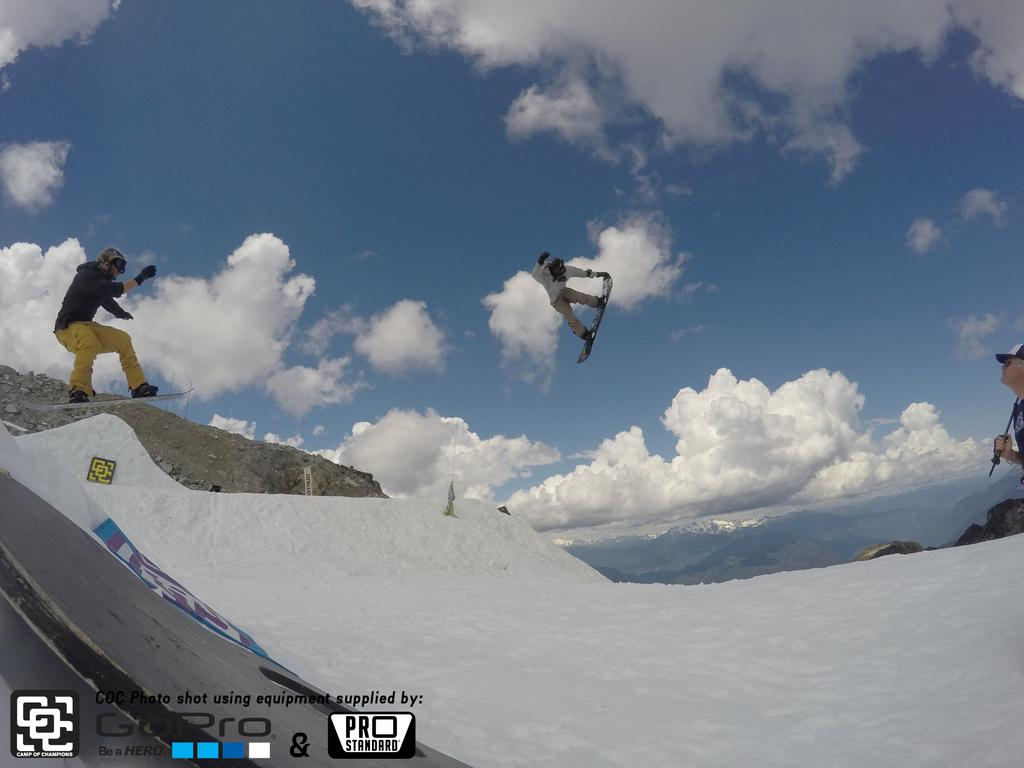What are the two persons in the image doing? The two persons in the image are skiing. What type of terrain can be seen at the bottom of the image? There is snow at the bottom of the image. What is visible in the sky in the background of the image? There are clouds in the sky in the background of the image. Can you see any flowers or a bridge in the image? No, there are no flowers or bridge visible in the image. 